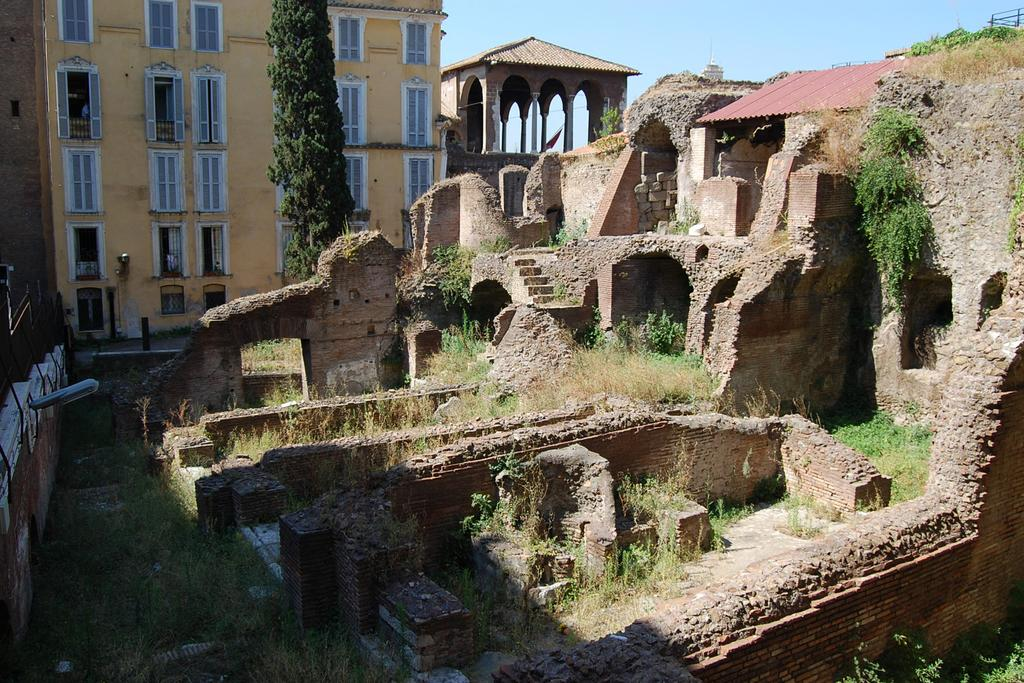What type of structures can be seen in the image? There are monuments and buildings in the image. What is located in front of the buildings? Trees are visible in front of the buildings. What type of vegetation is at the bottom of the image? Grass is present at the bottom of the image. What is visible at the top of the image? The sky is visible at the top of the image. Can you see any farmers working in the fields in the image? There are no farmers or fields present in the image; it features monuments, buildings, trees, grass, and the sky. 